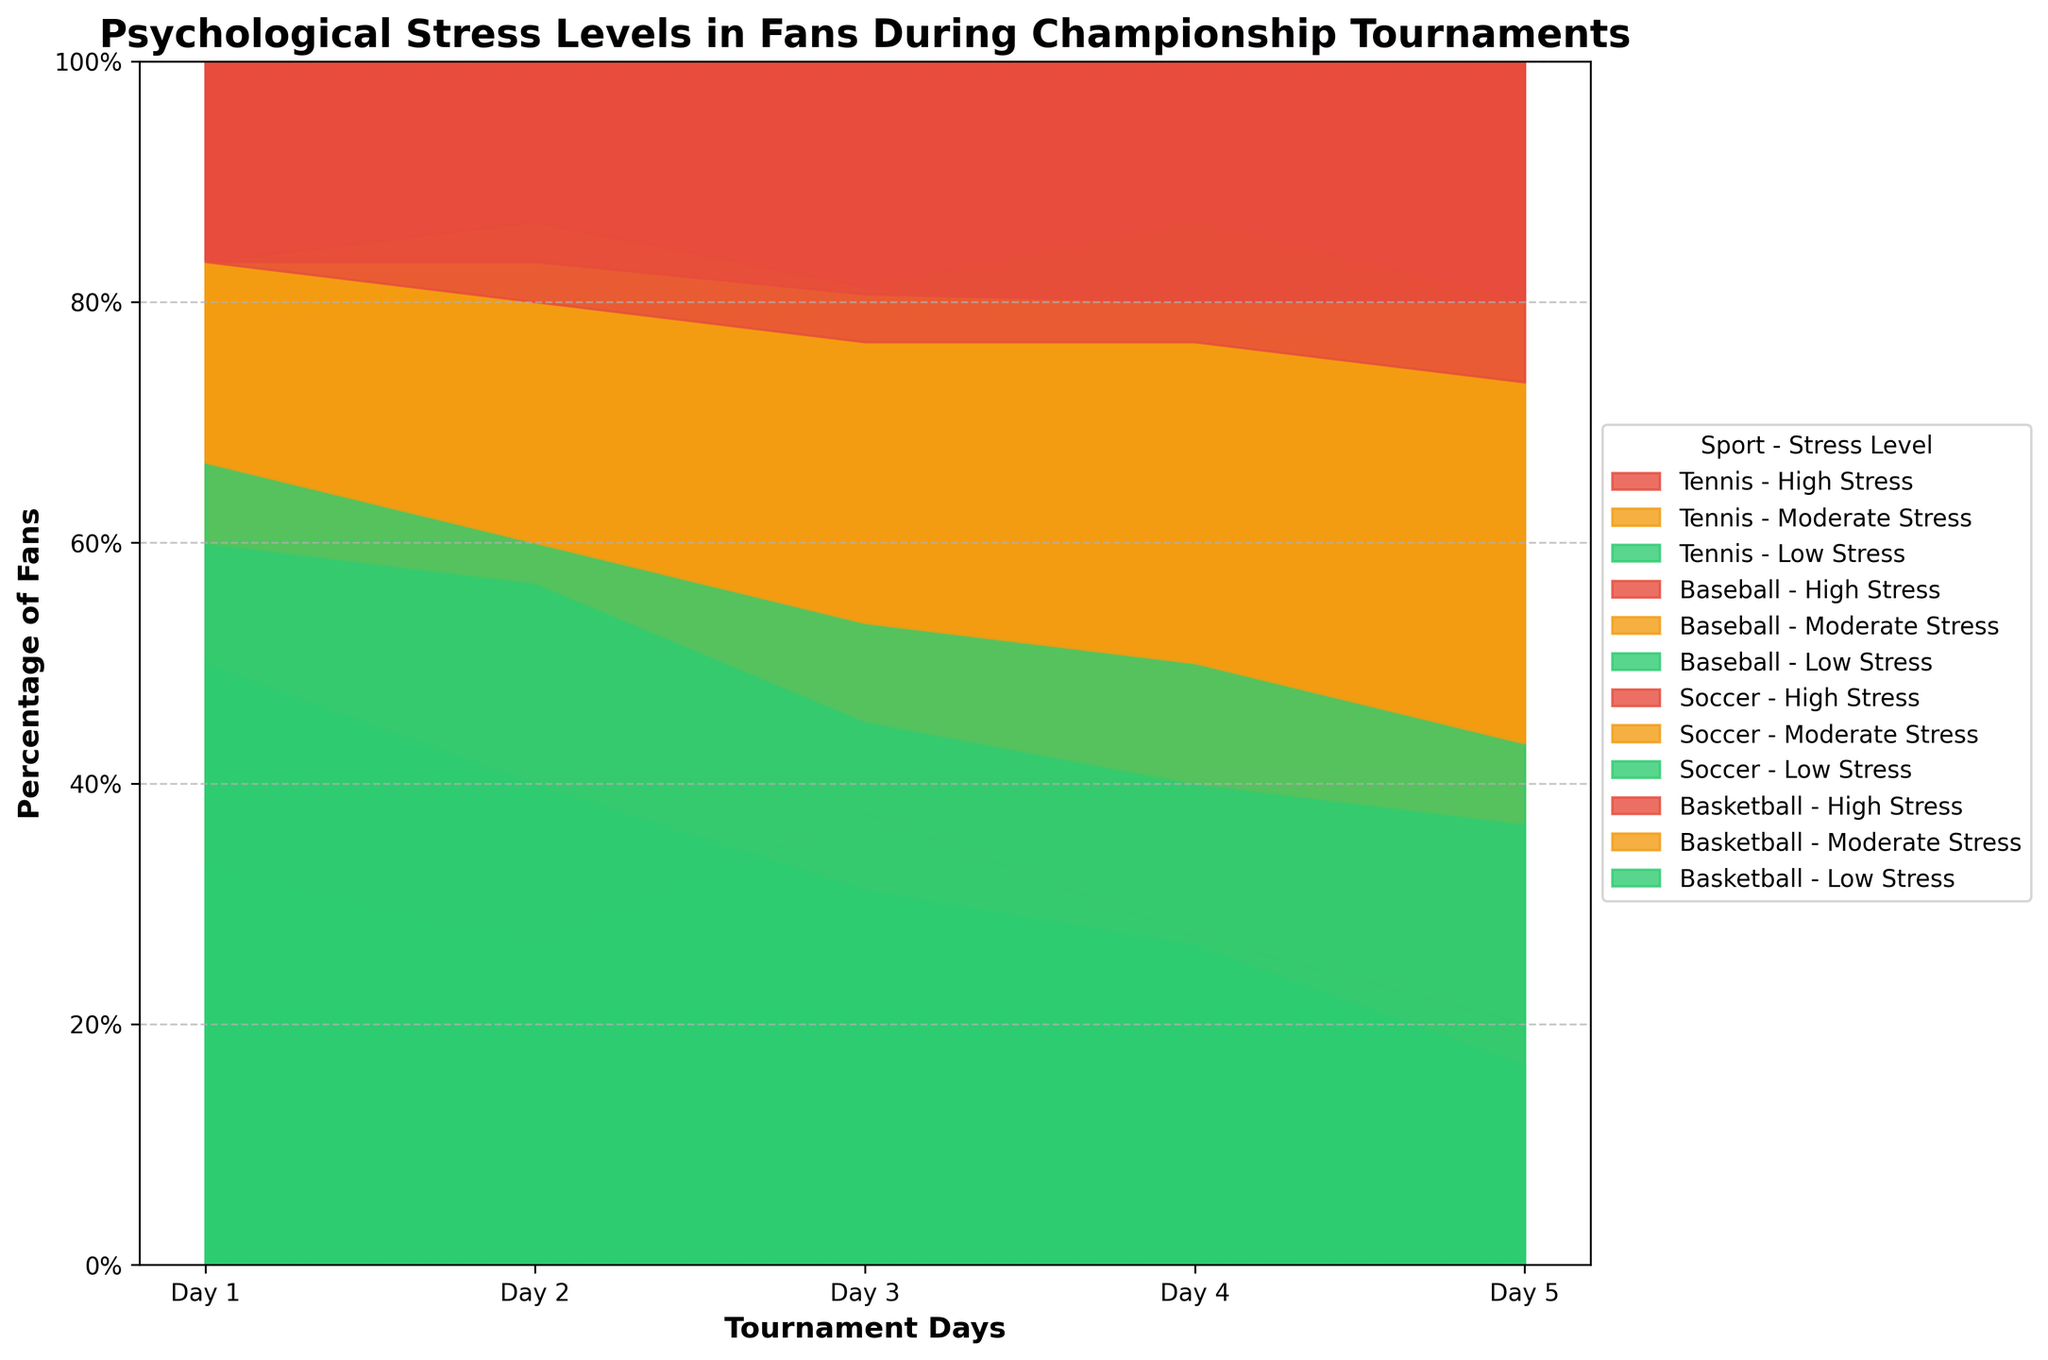What is the title of the chart? The title is displayed at the top of the chart and is intended to give a brief overview of what the chart is about.
Answer: Psychological Stress Levels in Fans During Championship Tournaments How many days are represented in the chart? To determine this, count the unique days presented along the x-axis.
Answer: 5 days Which sport has the highest percentage of low-stress fans on Day 1? Look at the portion of the area marked with the color for low stress on Day 1 for each sport.
Answer: Tennis On which day do basketball fans experience the highest percentage of high stress? Observe the heights of the high-stress sections for each day in the basketball category and identify the tallest one.
Answer: Day 5 What is the combined percentage of fans experiencing moderate and high stress in soccer on Day 4? Add the heights of the moderate stress and high stress areas for soccer on Day 4.
Answer: 22% Which sport shows a decreasing trend in low-stress fans over the days? Analyze the trend of the area representing low stress for each sport and see which one shows a consistent decrease.
Answer: Tennis How does the percentage of fans experiencing high stress in baseball on Day 3 compare to Day 5? Compare the heights of the high-stress sections in the baseball category on Day 3 and Day 5.
Answer: Same (6%) What is the difference in the percentage of low-stress fans between soccer and basketball on Day 5? Subtract the percentage of low-stress fans in basketball from that in soccer on Day 5.
Answer: 1% Which sport has the least variation in the percentage of high-stress fans over the tournament days? Assess the height difference of the high-stress areas across all days for each sport and identify the one with the least fluctuation.
Answer: Baseball 